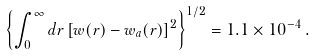Convert formula to latex. <formula><loc_0><loc_0><loc_500><loc_500>\left \{ \int _ { 0 } ^ { \infty } d r \left [ w ( r ) - w _ { a } ( r ) \right ] ^ { 2 } \right \} ^ { 1 / 2 } = 1 . 1 \times 1 0 ^ { - 4 } \, .</formula> 